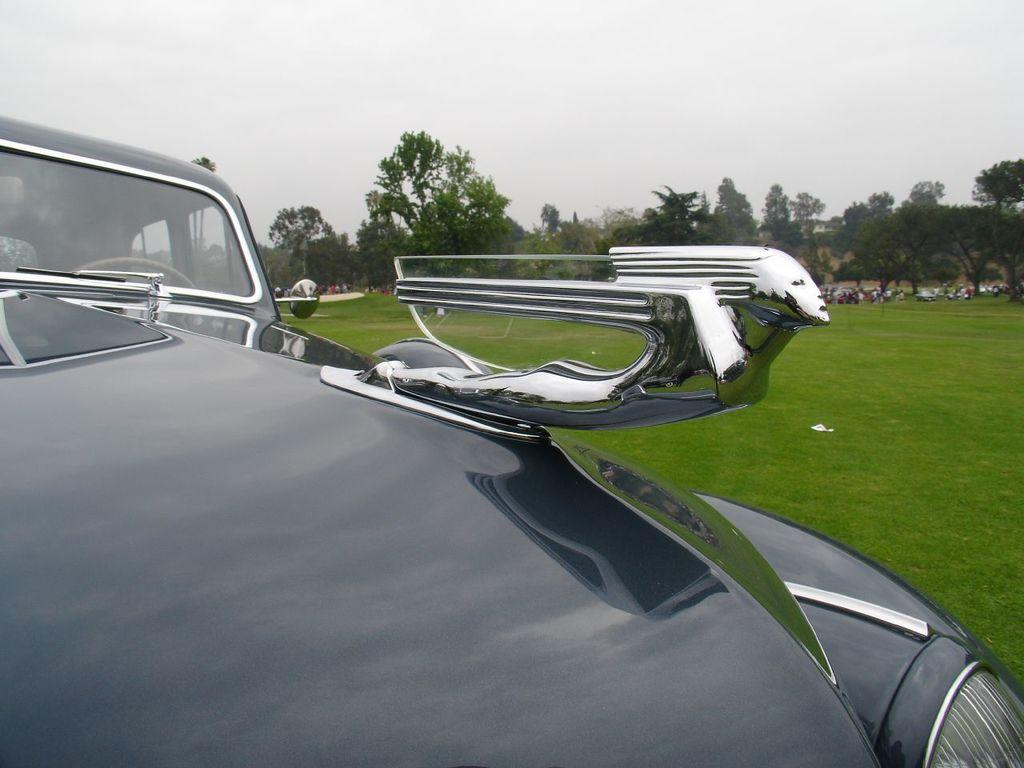What is the main subject of the image? There is a vehicle in the image. Are there any living beings in the image? Yes, there are people in the image. What type of terrain is visible in the image? There is grass on the ground in the image. What can be seen in the background of the image? There are trees in the background of the image. What is visible at the top of the image? The sky is visible at the top of the image. How many cherries are being eaten by the snails in the image? There are no cherries or snails present in the image. 